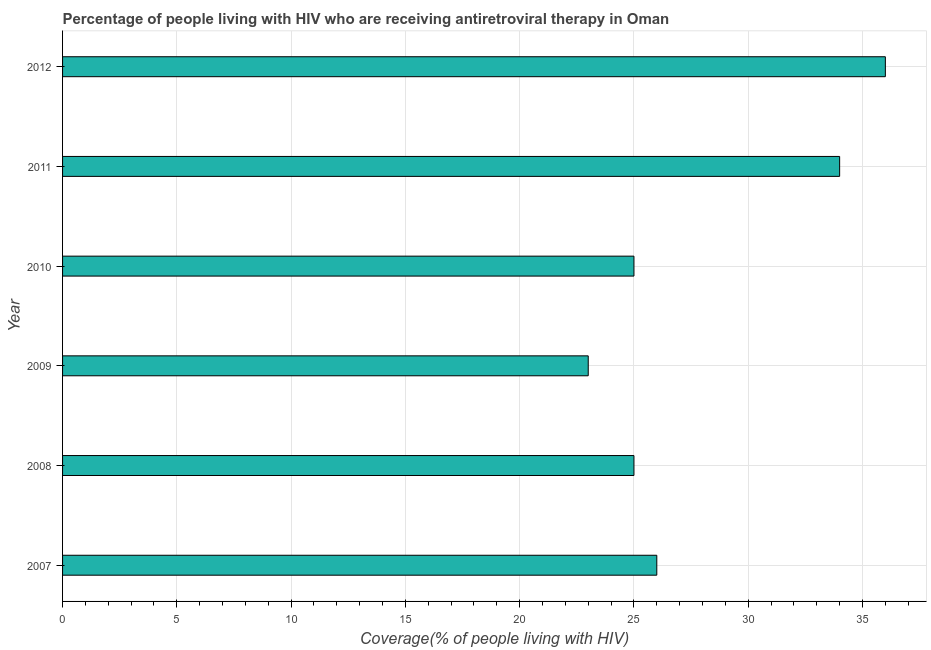Does the graph contain any zero values?
Your response must be concise. No. Does the graph contain grids?
Ensure brevity in your answer.  Yes. What is the title of the graph?
Give a very brief answer. Percentage of people living with HIV who are receiving antiretroviral therapy in Oman. What is the label or title of the X-axis?
Offer a terse response. Coverage(% of people living with HIV). Across all years, what is the maximum antiretroviral therapy coverage?
Your answer should be very brief. 36. Across all years, what is the minimum antiretroviral therapy coverage?
Give a very brief answer. 23. In which year was the antiretroviral therapy coverage minimum?
Provide a succinct answer. 2009. What is the sum of the antiretroviral therapy coverage?
Offer a very short reply. 169. In how many years, is the antiretroviral therapy coverage greater than 15 %?
Your response must be concise. 6. Is the sum of the antiretroviral therapy coverage in 2007 and 2010 greater than the maximum antiretroviral therapy coverage across all years?
Make the answer very short. Yes. In how many years, is the antiretroviral therapy coverage greater than the average antiretroviral therapy coverage taken over all years?
Your answer should be very brief. 2. How many bars are there?
Provide a succinct answer. 6. Are all the bars in the graph horizontal?
Your answer should be very brief. Yes. How many years are there in the graph?
Give a very brief answer. 6. What is the difference between two consecutive major ticks on the X-axis?
Offer a very short reply. 5. Are the values on the major ticks of X-axis written in scientific E-notation?
Give a very brief answer. No. What is the Coverage(% of people living with HIV) in 2010?
Your response must be concise. 25. What is the Coverage(% of people living with HIV) of 2011?
Offer a terse response. 34. What is the Coverage(% of people living with HIV) in 2012?
Provide a succinct answer. 36. What is the difference between the Coverage(% of people living with HIV) in 2007 and 2008?
Your answer should be very brief. 1. What is the difference between the Coverage(% of people living with HIV) in 2007 and 2011?
Offer a terse response. -8. What is the difference between the Coverage(% of people living with HIV) in 2008 and 2010?
Ensure brevity in your answer.  0. What is the difference between the Coverage(% of people living with HIV) in 2009 and 2010?
Provide a short and direct response. -2. What is the difference between the Coverage(% of people living with HIV) in 2010 and 2012?
Your answer should be compact. -11. What is the difference between the Coverage(% of people living with HIV) in 2011 and 2012?
Provide a short and direct response. -2. What is the ratio of the Coverage(% of people living with HIV) in 2007 to that in 2009?
Your answer should be very brief. 1.13. What is the ratio of the Coverage(% of people living with HIV) in 2007 to that in 2011?
Your answer should be compact. 0.77. What is the ratio of the Coverage(% of people living with HIV) in 2007 to that in 2012?
Provide a short and direct response. 0.72. What is the ratio of the Coverage(% of people living with HIV) in 2008 to that in 2009?
Offer a very short reply. 1.09. What is the ratio of the Coverage(% of people living with HIV) in 2008 to that in 2011?
Offer a terse response. 0.73. What is the ratio of the Coverage(% of people living with HIV) in 2008 to that in 2012?
Provide a succinct answer. 0.69. What is the ratio of the Coverage(% of people living with HIV) in 2009 to that in 2011?
Make the answer very short. 0.68. What is the ratio of the Coverage(% of people living with HIV) in 2009 to that in 2012?
Offer a very short reply. 0.64. What is the ratio of the Coverage(% of people living with HIV) in 2010 to that in 2011?
Make the answer very short. 0.73. What is the ratio of the Coverage(% of people living with HIV) in 2010 to that in 2012?
Keep it short and to the point. 0.69. What is the ratio of the Coverage(% of people living with HIV) in 2011 to that in 2012?
Keep it short and to the point. 0.94. 